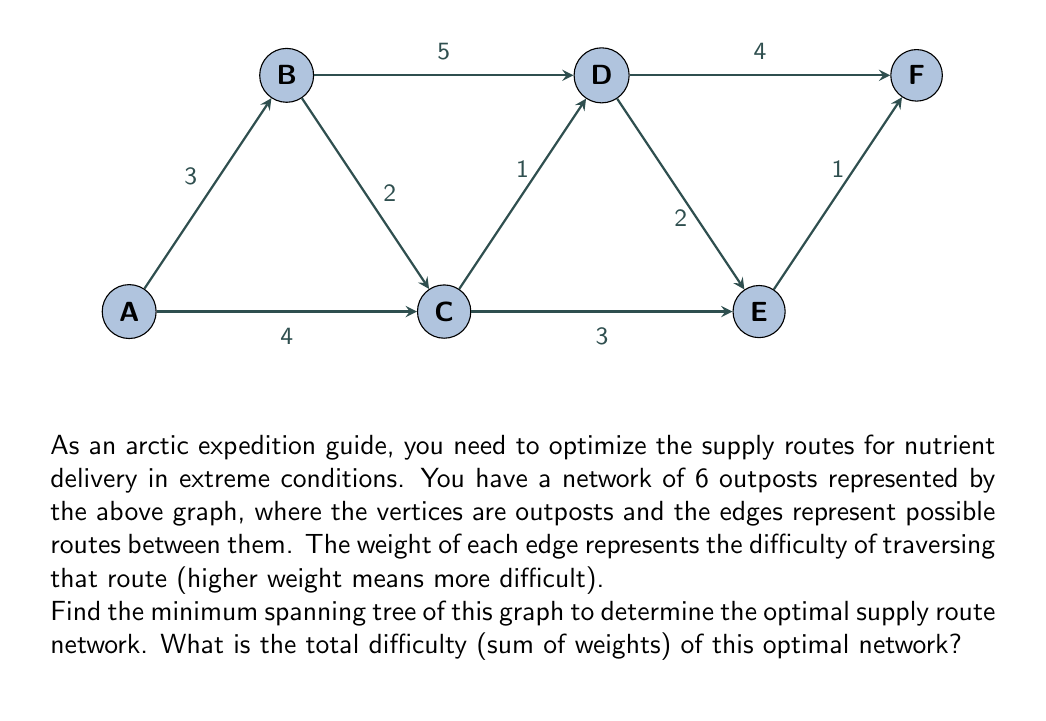Teach me how to tackle this problem. To find the minimum spanning tree (MST) of this graph, we can use Kruskal's algorithm. Here's a step-by-step solution:

1) First, sort all edges by weight in ascending order:
   (C,D): 1
   (E,F): 1
   (B,C): 2
   (D,E): 2
   (A,B): 3
   (C,E): 3
   (A,C): 4
   (D,F): 4
   (B,D): 5

2) Now, we'll add edges to our MST, starting with the lowest weight, as long as they don't create a cycle:

   - Add (C,D): 1
   - Add (E,F): 1
   - Add (B,C): 2
   - Add (D,E): 2
   - Add (A,B): 3

3) At this point, we have added 5 edges, which is enough for our MST (number of vertices - 1 = 6 - 1 = 5).

4) The edges in our MST are:
   (C,D), (E,F), (B,C), (D,E), (A,B)

5) To calculate the total difficulty, we sum the weights of these edges:
   $$1 + 1 + 2 + 2 + 3 = 9$$

Therefore, the total difficulty (sum of weights) of the optimal network is 9.
Answer: 9 